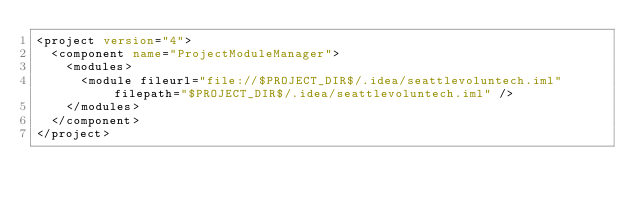<code> <loc_0><loc_0><loc_500><loc_500><_XML_><project version="4">
  <component name="ProjectModuleManager">
    <modules>
      <module fileurl="file://$PROJECT_DIR$/.idea/seattlevoluntech.iml" filepath="$PROJECT_DIR$/.idea/seattlevoluntech.iml" />
    </modules>
  </component>
</project></code> 